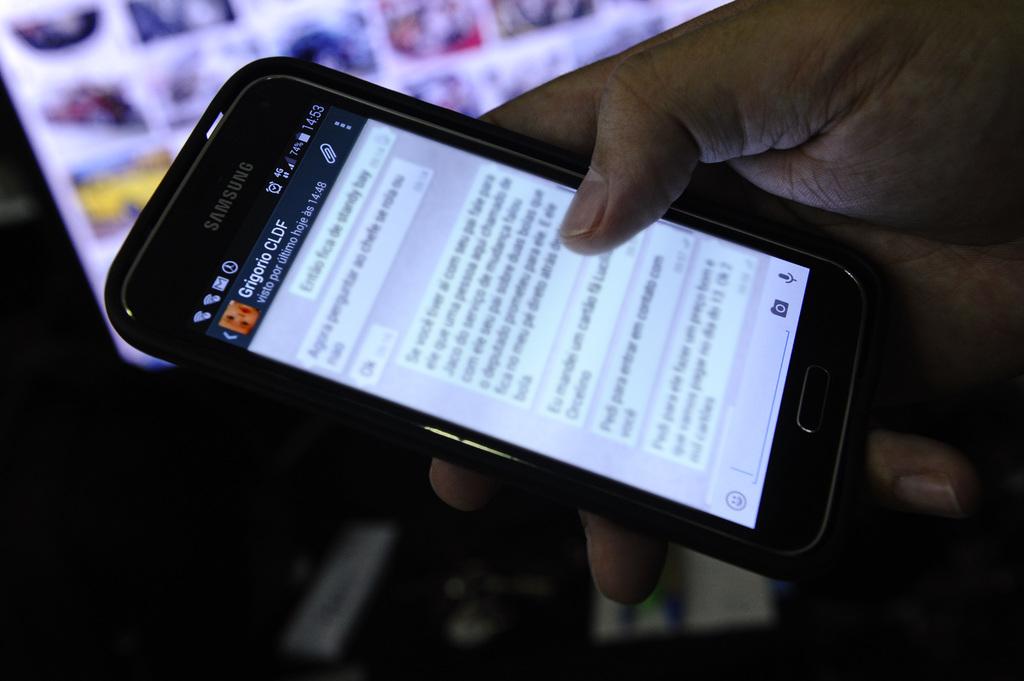Who is the person messaging?
Give a very brief answer. Grigorio cldf. 